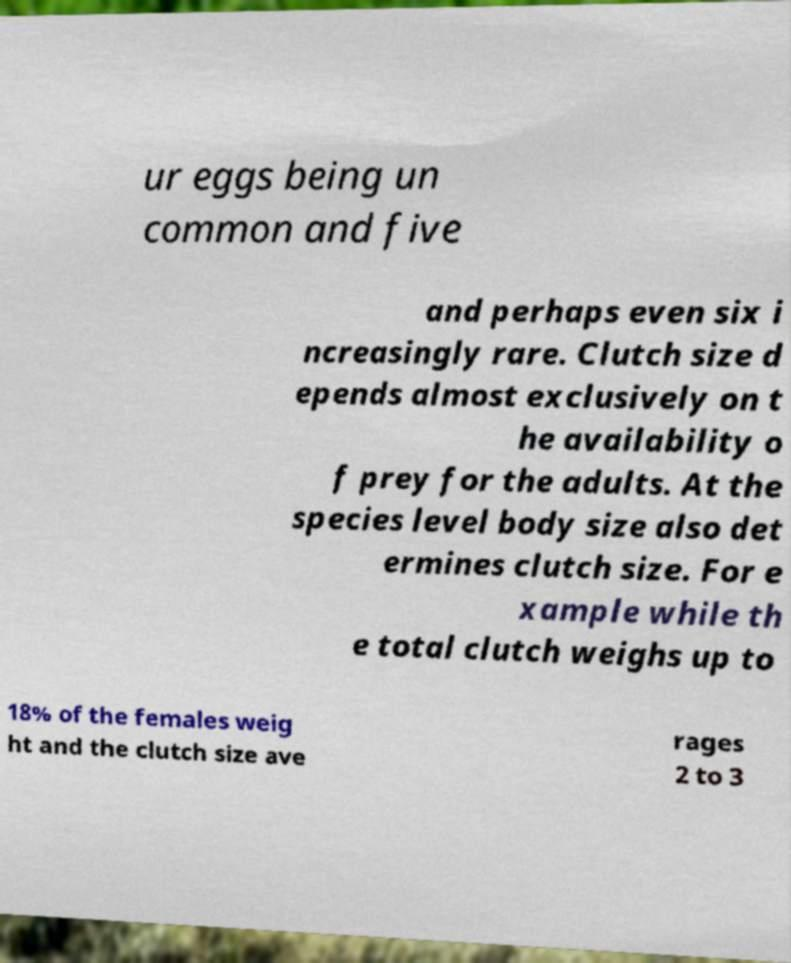What messages or text are displayed in this image? I need them in a readable, typed format. ur eggs being un common and five and perhaps even six i ncreasingly rare. Clutch size d epends almost exclusively on t he availability o f prey for the adults. At the species level body size also det ermines clutch size. For e xample while th e total clutch weighs up to 18% of the females weig ht and the clutch size ave rages 2 to 3 